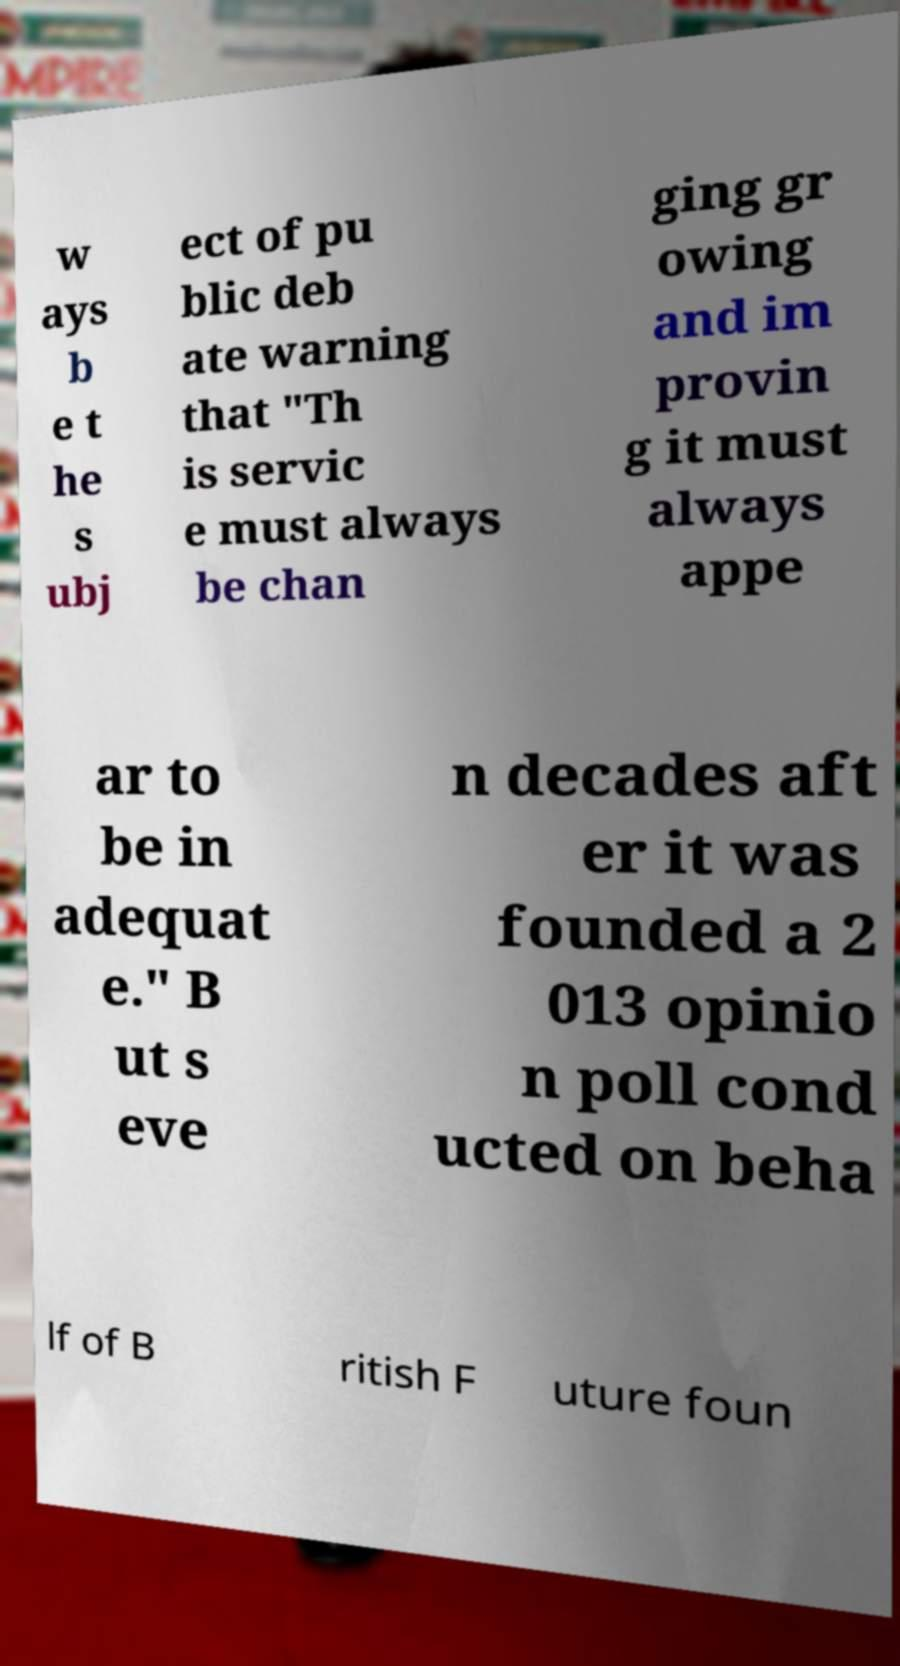Can you accurately transcribe the text from the provided image for me? w ays b e t he s ubj ect of pu blic deb ate warning that "Th is servic e must always be chan ging gr owing and im provin g it must always appe ar to be in adequat e." B ut s eve n decades aft er it was founded a 2 013 opinio n poll cond ucted on beha lf of B ritish F uture foun 